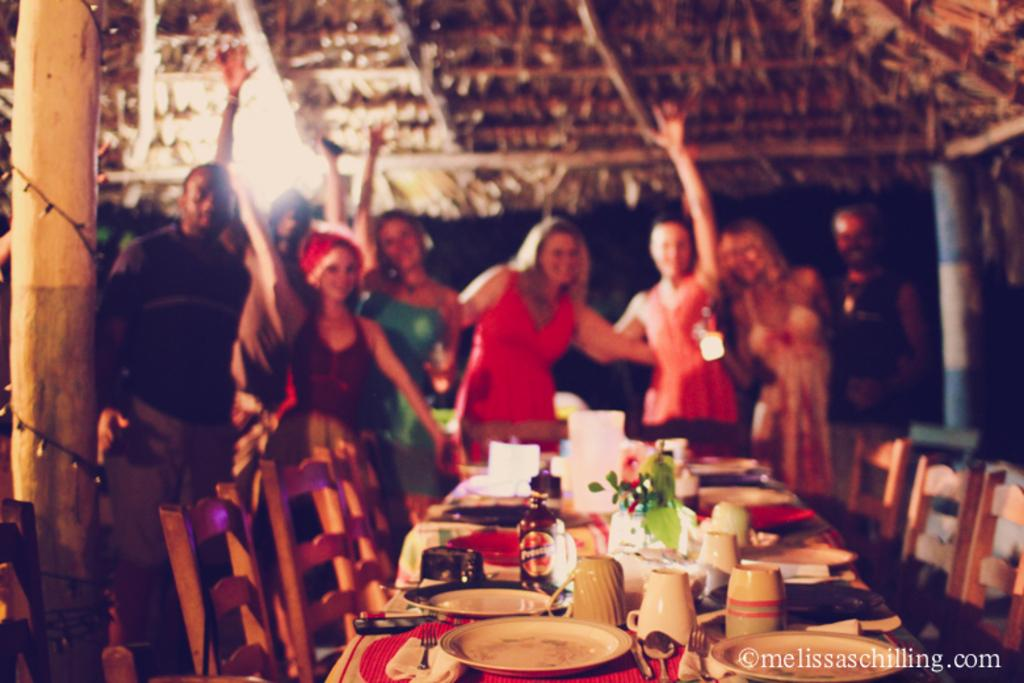How many people are in the image? There is a group of people in the image, but the exact number is not specified. What are the people doing in the image? The people are standing behind a table. What is on the table in the image? There is a small plant, plates, cups, and other unspecified items on the table. What type of structure is visible in the background of the image? There is no structure visible in the background of the image. Can you see a train passing by in the image? There is no train present in the image. 